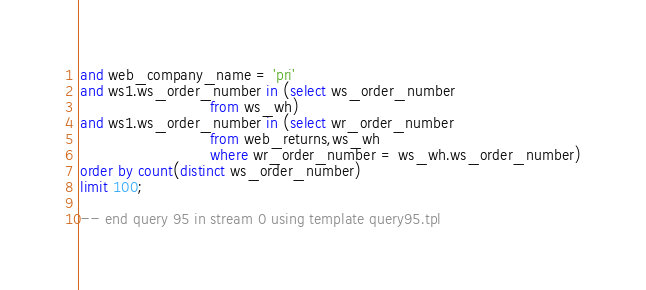<code> <loc_0><loc_0><loc_500><loc_500><_SQL_>and web_company_name = 'pri'
and ws1.ws_order_number in (select ws_order_number
                            from ws_wh)
and ws1.ws_order_number in (select wr_order_number
                            from web_returns,ws_wh
                            where wr_order_number = ws_wh.ws_order_number)
order by count(distinct ws_order_number)
limit 100;

-- end query 95 in stream 0 using template query95.tpl
</code> 